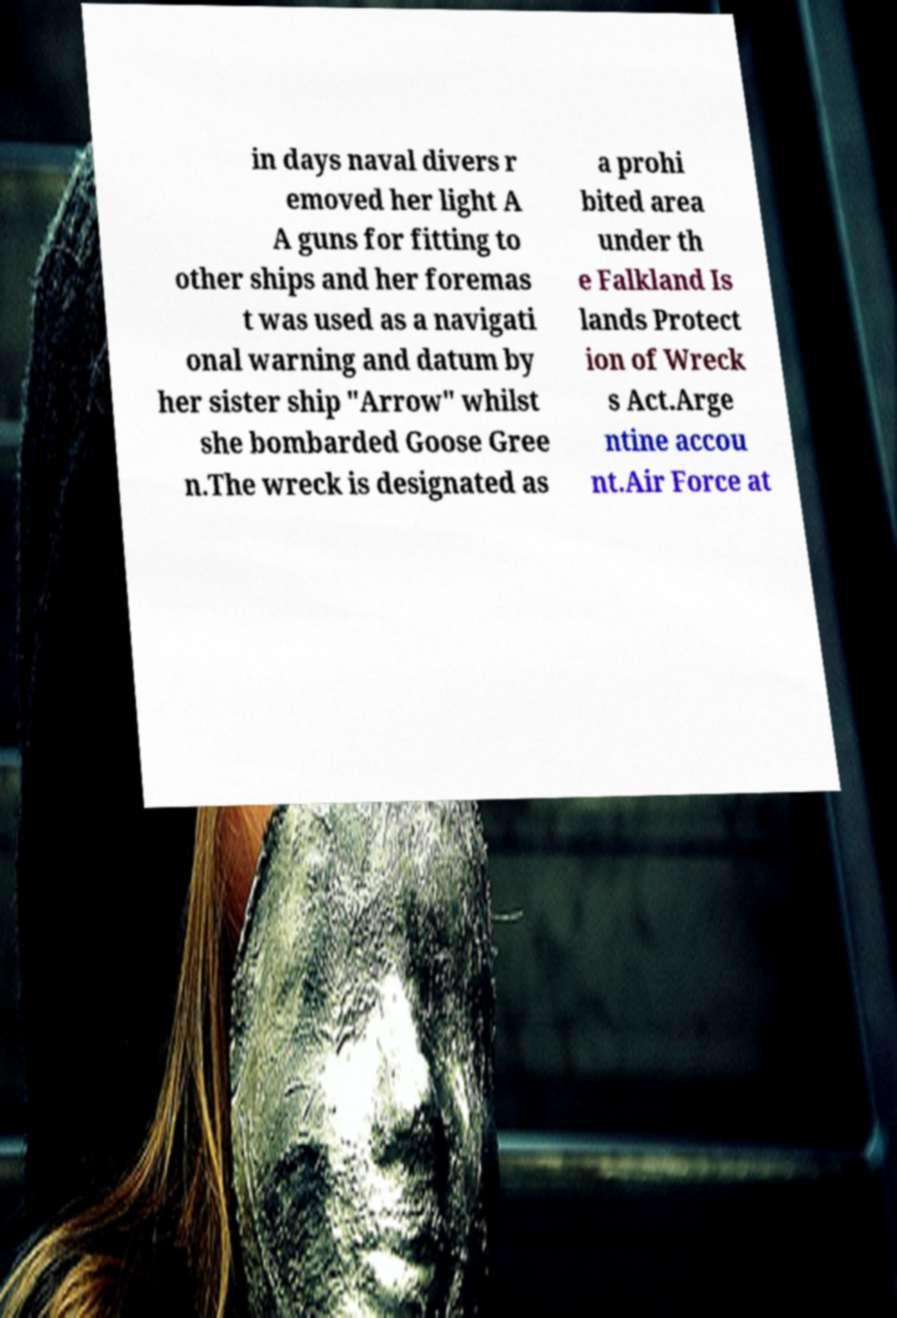Could you assist in decoding the text presented in this image and type it out clearly? in days naval divers r emoved her light A A guns for fitting to other ships and her foremas t was used as a navigati onal warning and datum by her sister ship "Arrow" whilst she bombarded Goose Gree n.The wreck is designated as a prohi bited area under th e Falkland Is lands Protect ion of Wreck s Act.Arge ntine accou nt.Air Force at 